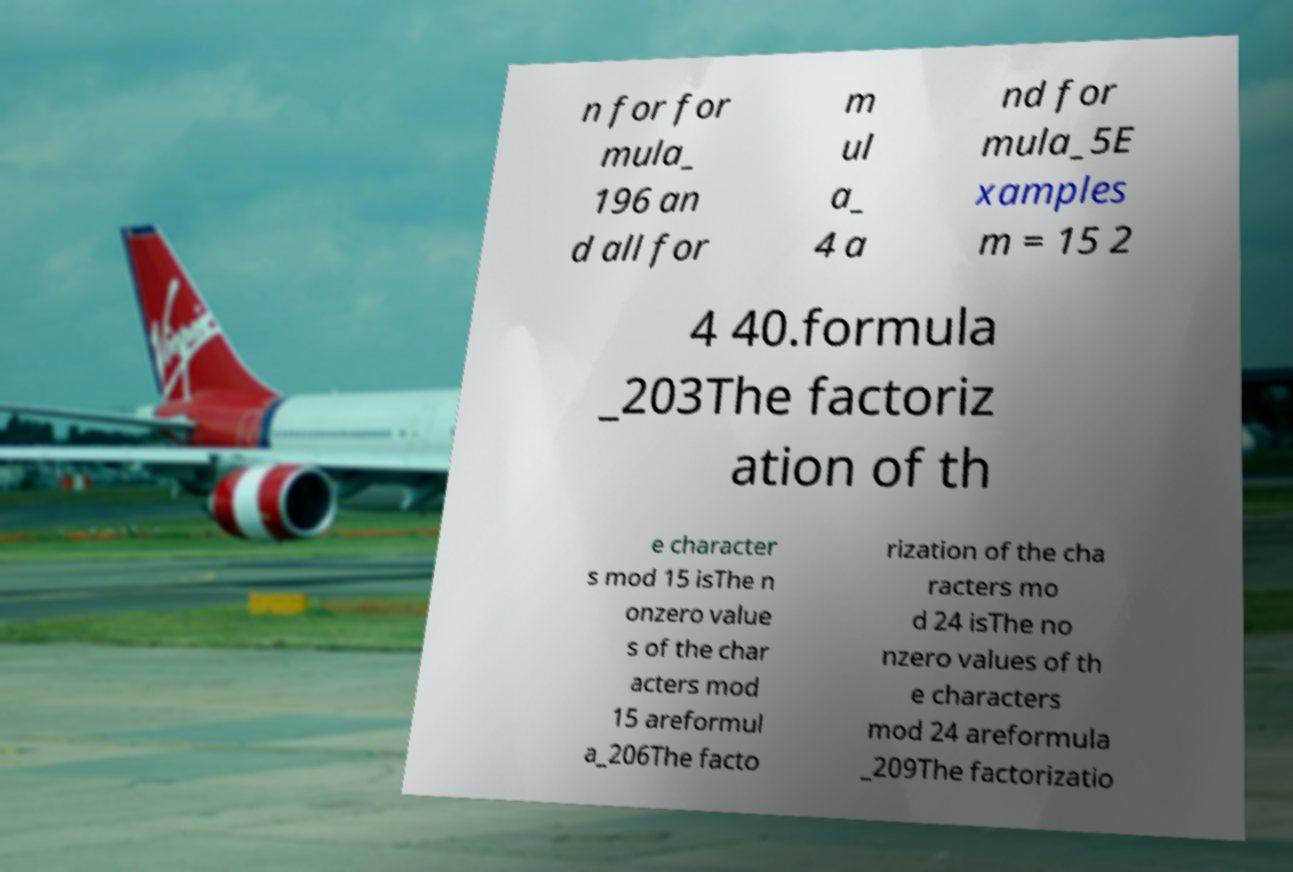What messages or text are displayed in this image? I need them in a readable, typed format. n for for mula_ 196 an d all for m ul a_ 4 a nd for mula_5E xamples m = 15 2 4 40.formula _203The factoriz ation of th e character s mod 15 isThe n onzero value s of the char acters mod 15 areformul a_206The facto rization of the cha racters mo d 24 isThe no nzero values of th e characters mod 24 areformula _209The factorizatio 